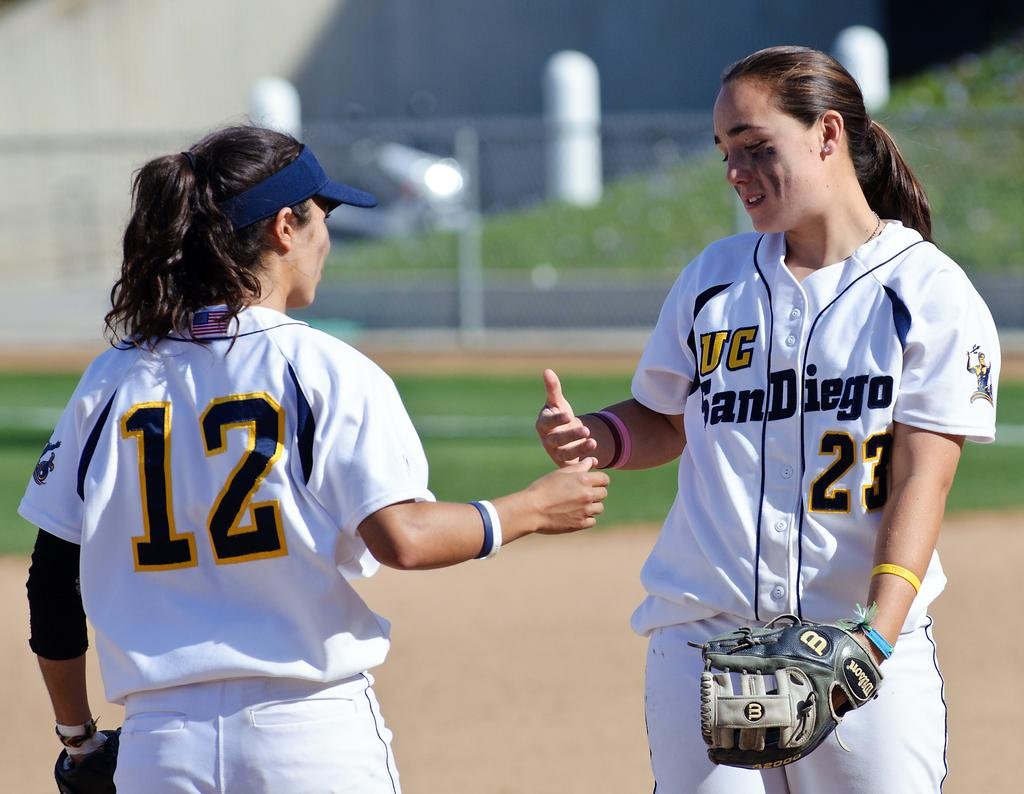<image>
Create a compact narrative representing the image presented. a couple of girls high fiving and one has the number 12 on 